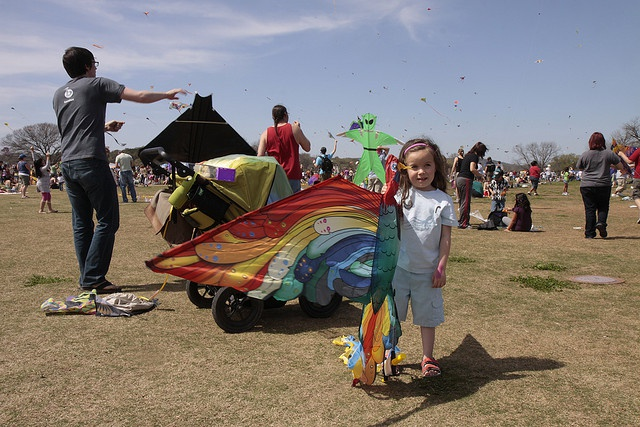Describe the objects in this image and their specific colors. I can see kite in darkgray, maroon, black, and brown tones, people in darkgray, black, and gray tones, kite in darkgray, black, and gray tones, people in darkgray, gray, black, and lightgray tones, and kite in darkgray, black, teal, olive, and gray tones in this image. 